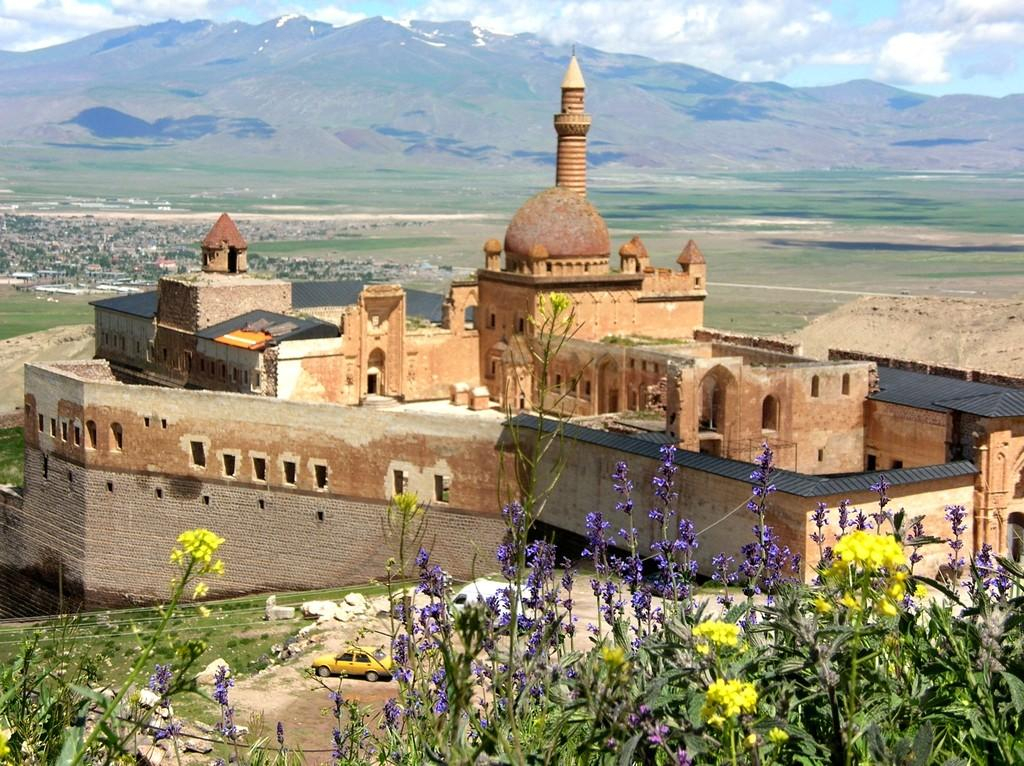What type of plants are at the bottom side of the image? There are flower plants at the bottom side of the image. What else can be seen in the image besides the flower plants? There are vehicles and a castle-like structure in the image. What is the background of the image like? The background of the image includes greenery, mountains, and the sky. Can you tell me how many bears are visible in the image? There are no bears present in the image. What type of houses can be seen in the background of the image? There are no houses visible in the image; it features a castle-like structure and mountains in the background. 